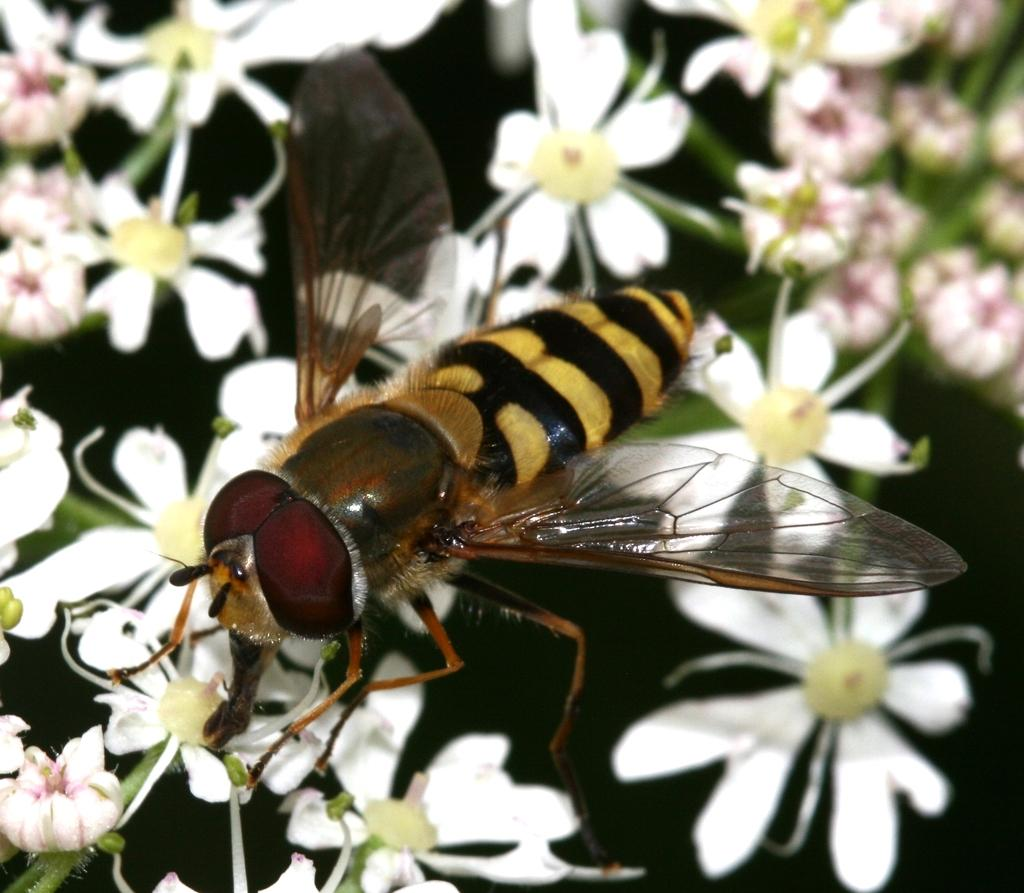What type of insect is in the image? There is a honey bee in the image. Where is the honey bee located in the image? The honey bee is on the flowers. What color are the flowers in the image? The flowers in the image are white. What type of cork can be seen in the image? There is no cork present in the image. What type of plant is growing in the tent in the image? There is no tent present in the image, and therefore no plants growing inside it. 